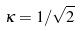<formula> <loc_0><loc_0><loc_500><loc_500>\kappa = 1 / \sqrt { 2 }</formula> 